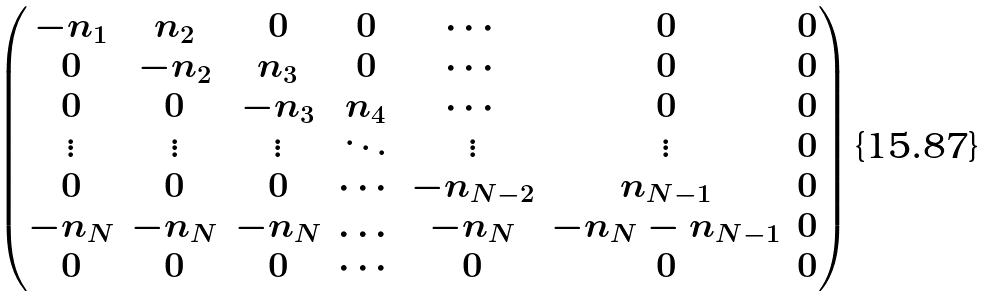Convert formula to latex. <formula><loc_0><loc_0><loc_500><loc_500>\left ( \begin{matrix} - n _ { 1 } & n _ { 2 } & 0 & 0 & \cdots & 0 & 0 \\ 0 & - n _ { 2 } & n _ { 3 } & 0 & \cdots & 0 & 0 \\ 0 & 0 & - n _ { 3 } & n _ { 4 } & \cdots & 0 & 0 \\ \vdots & \vdots & \vdots & \ddots & \vdots & \vdots & 0 \\ 0 & 0 & 0 & \cdots & - n _ { N - 2 } & n _ { N - 1 } & 0 \\ - n _ { N } & - n _ { N } & - n _ { N } & \dots & - n _ { N } & - n _ { N } - n _ { N - 1 } & 0 \\ 0 & 0 & 0 & \cdots & 0 & 0 & 0 \end{matrix} \right )</formula> 